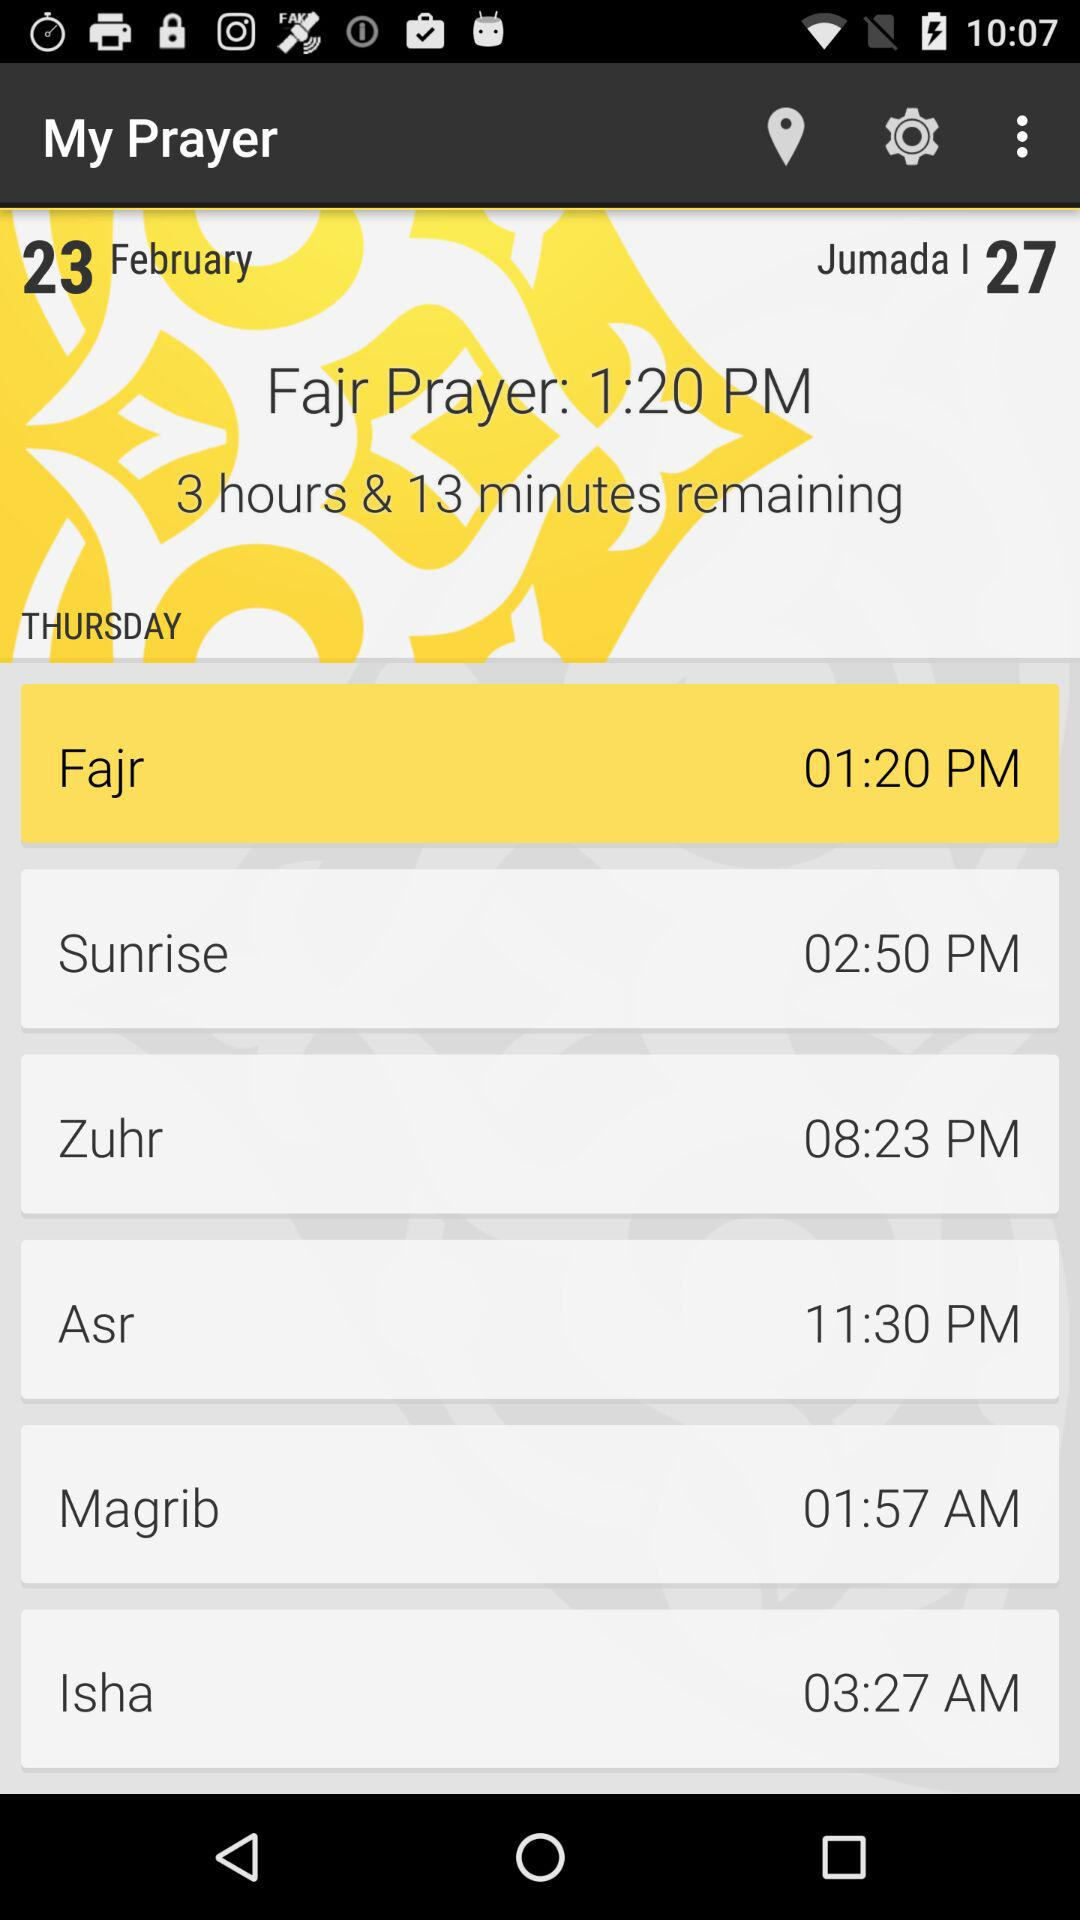What is the given day? The given day is Thursday. 